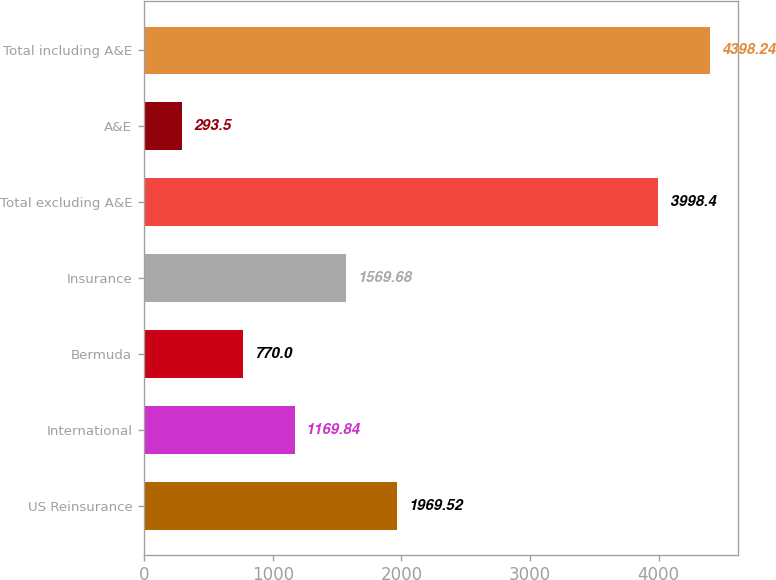Convert chart to OTSL. <chart><loc_0><loc_0><loc_500><loc_500><bar_chart><fcel>US Reinsurance<fcel>International<fcel>Bermuda<fcel>Insurance<fcel>Total excluding A&E<fcel>A&E<fcel>Total including A&E<nl><fcel>1969.52<fcel>1169.84<fcel>770<fcel>1569.68<fcel>3998.4<fcel>293.5<fcel>4398.24<nl></chart> 